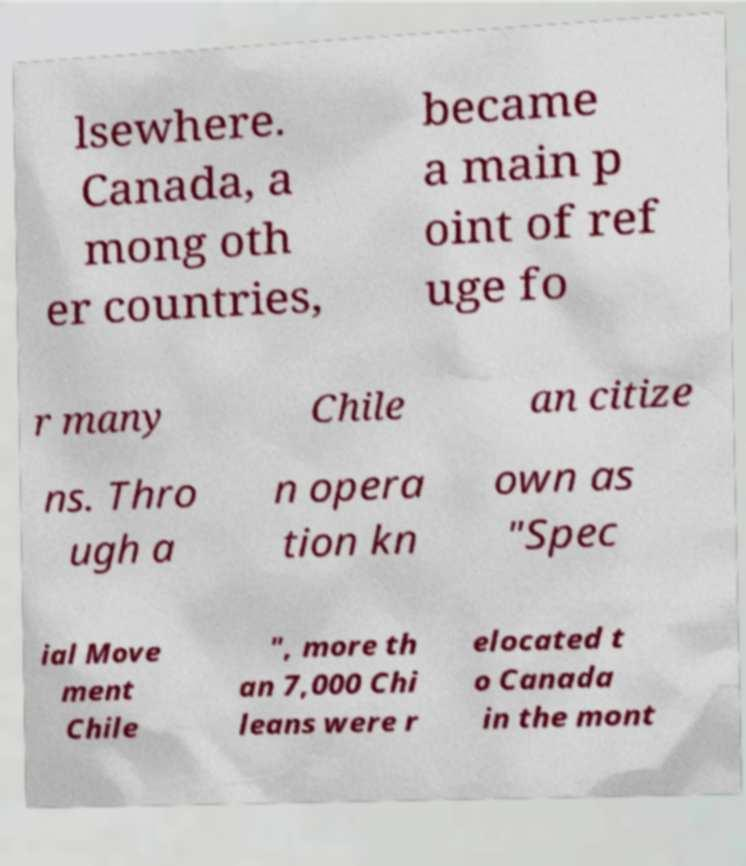Could you extract and type out the text from this image? lsewhere. Canada, a mong oth er countries, became a main p oint of ref uge fo r many Chile an citize ns. Thro ugh a n opera tion kn own as "Spec ial Move ment Chile ", more th an 7,000 Chi leans were r elocated t o Canada in the mont 